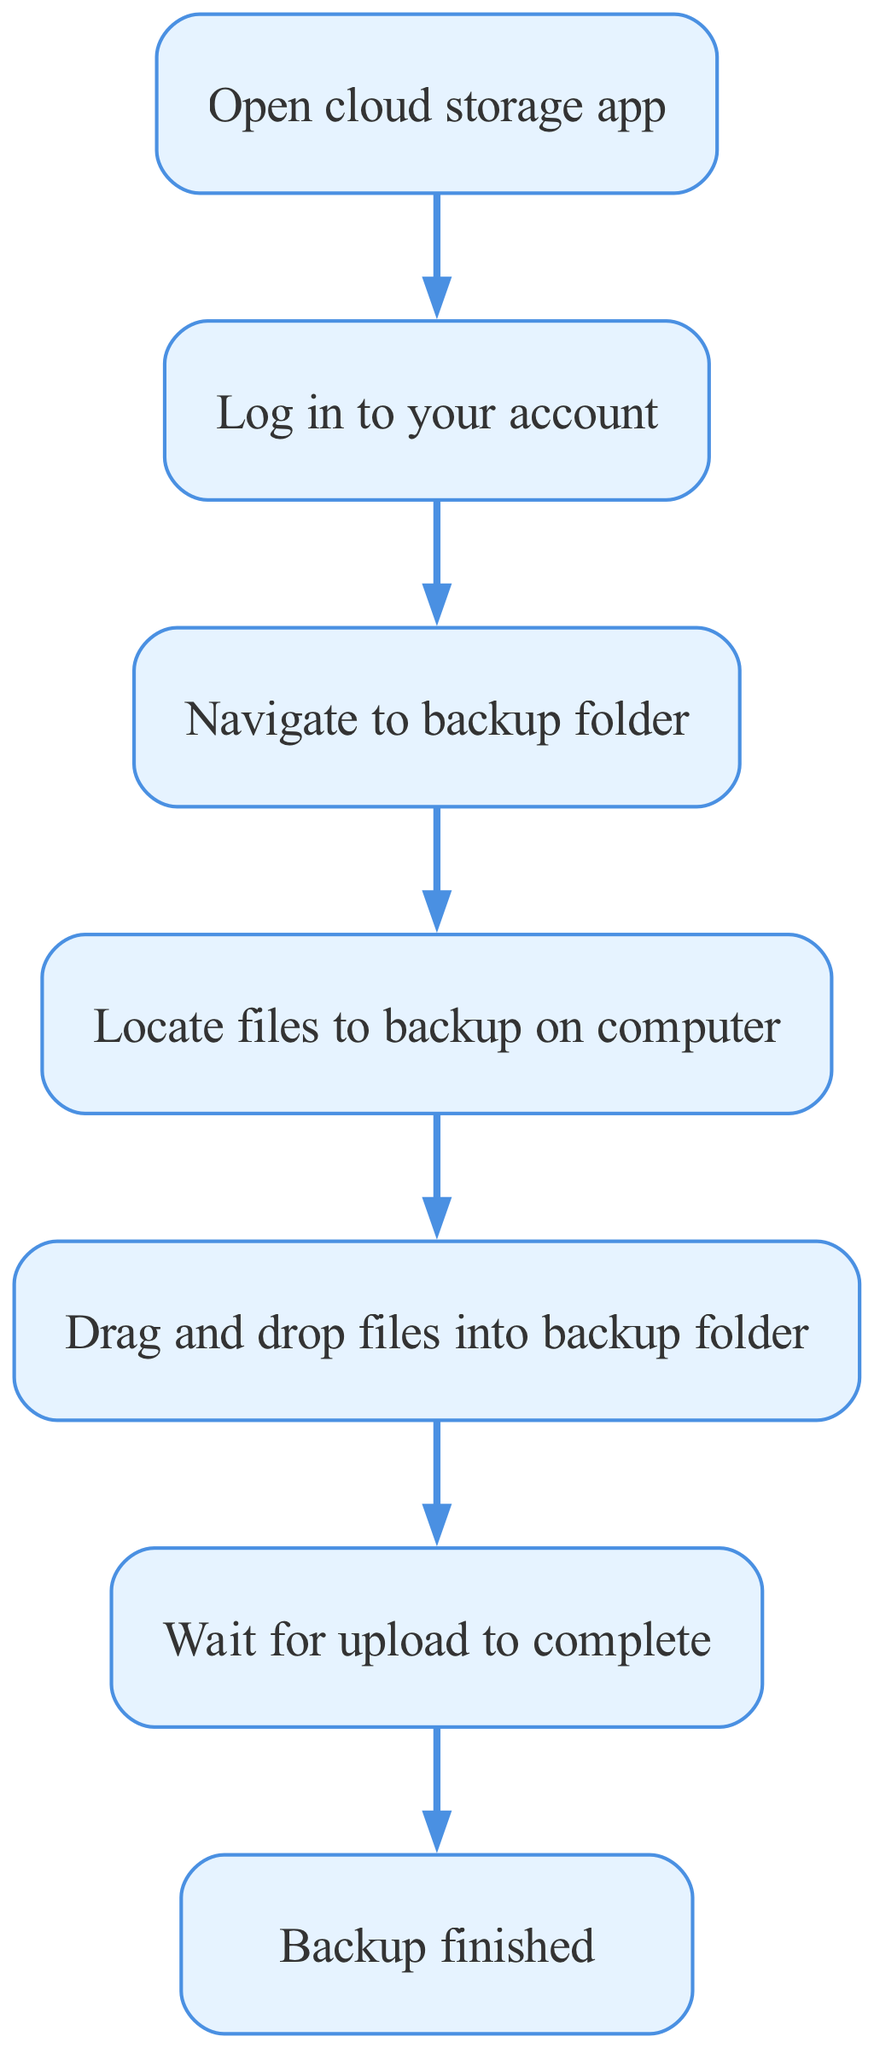What is the first step in the backup process? The first step in the diagram is to "Open cloud storage app". This can be found at the start of the flowchart, which leads to the next step.
Answer: Open cloud storage app How many steps are there in total? There are six steps in total, including the start and end points of the flowchart. The steps are clearly indicated in the diagram, and they include the start, five individual steps, and the end.
Answer: Six What do you do after logging in to your account? After logging in, the next step in the process is to "Navigate to backup folder". This follows directly after the login step in the flowchart.
Answer: Navigate to backup folder What is the final step in the backup process? The final step is "Backup finished", which indicates the completion of the entire process as shown in the endpoint of the flowchart.
Answer: Backup finished What is the relationship between "Locate files to backup on computer" and "Drag and drop files into backup folder"? The relationship is sequential; after locating files to back up on the computer, the next action is to "Drag and drop files into backup folder". This can be observed where the second step leads to the fourth step in the diagram.
Answer: Sequential How many nodes are directly linked to "Wait for upload to complete"? There is one node directly linked to "Wait for upload to complete", which is the "Drag and drop files into backup folder" step. This shows that uploading cannot start before files are dragged and dropped.
Answer: One What action is required before uploading files? Before uploading files, you must "Drag and drop files into backup folder". This action is indicated in the flow between locating files and waiting for the upload to complete.
Answer: Drag and drop files into backup folder After dragging and dropping files, what is the next immediate action? The next immediate action after dragging and dropping files is to "Wait for upload to complete". This action is shown as the next step following the drag-and-drop process.
Answer: Wait for upload to complete 